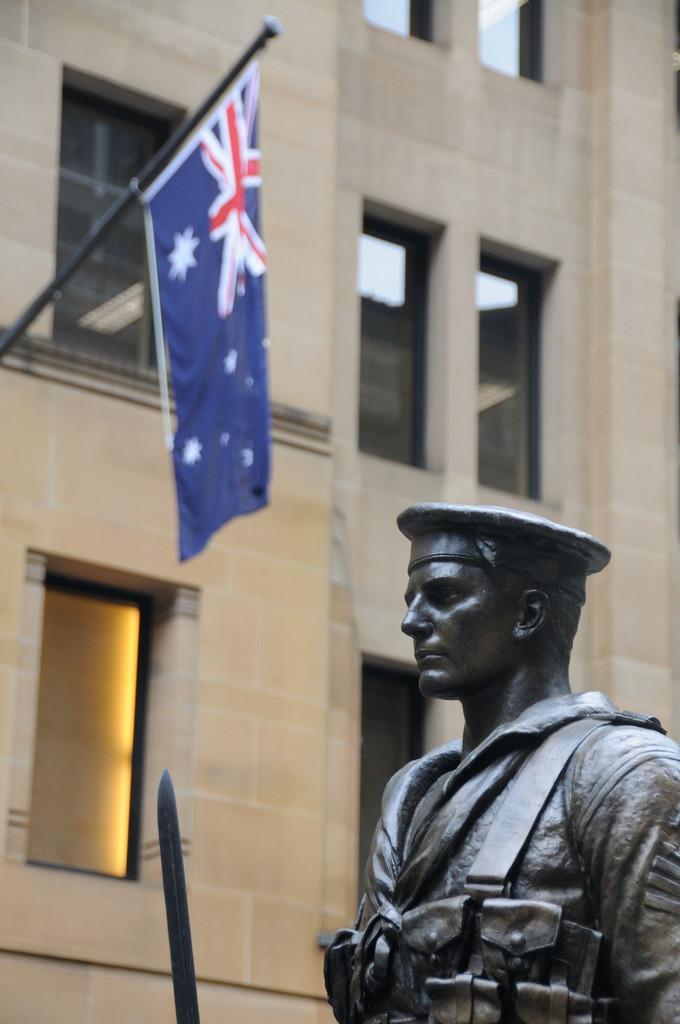Describe this image in one or two sentences. In this image there is a depiction of a person, in front of that there is an object. In the background there is a building and a flag. 